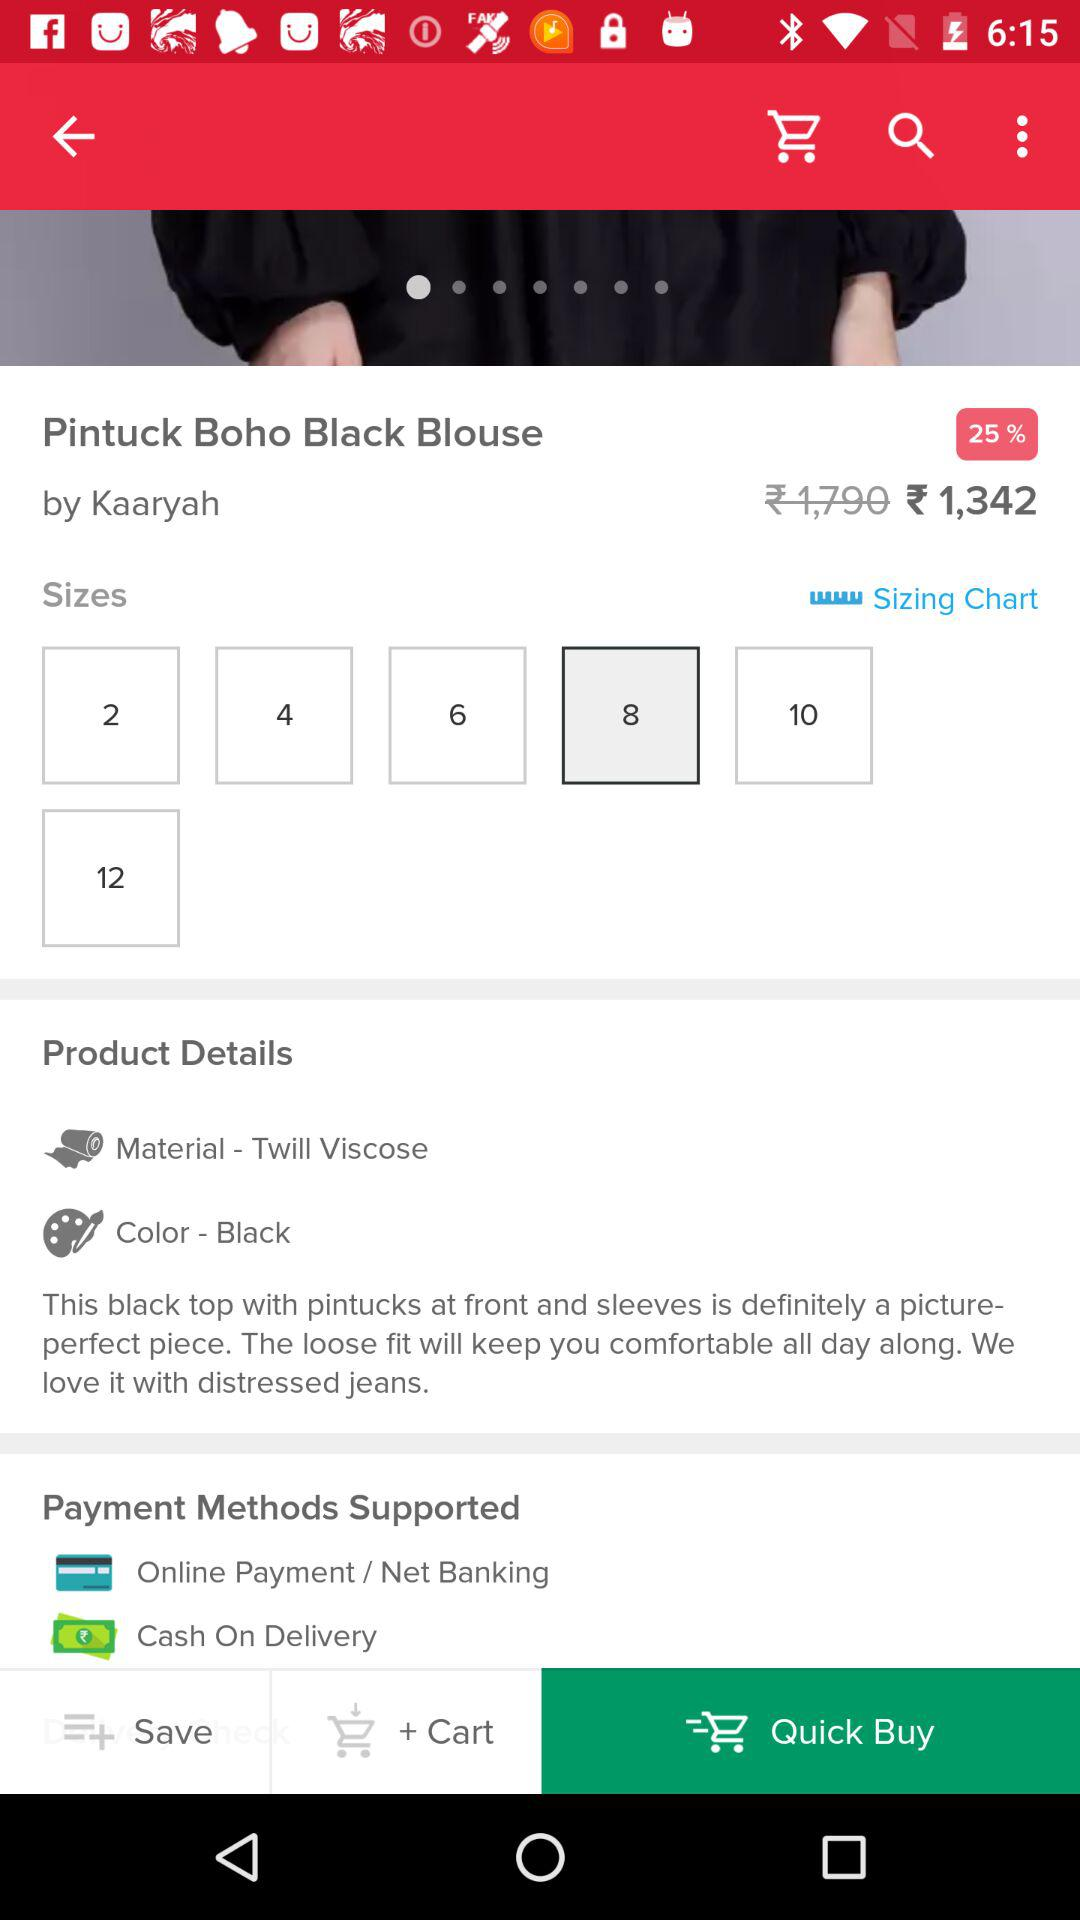What is the designer name? The designer name is Kaaryah. 